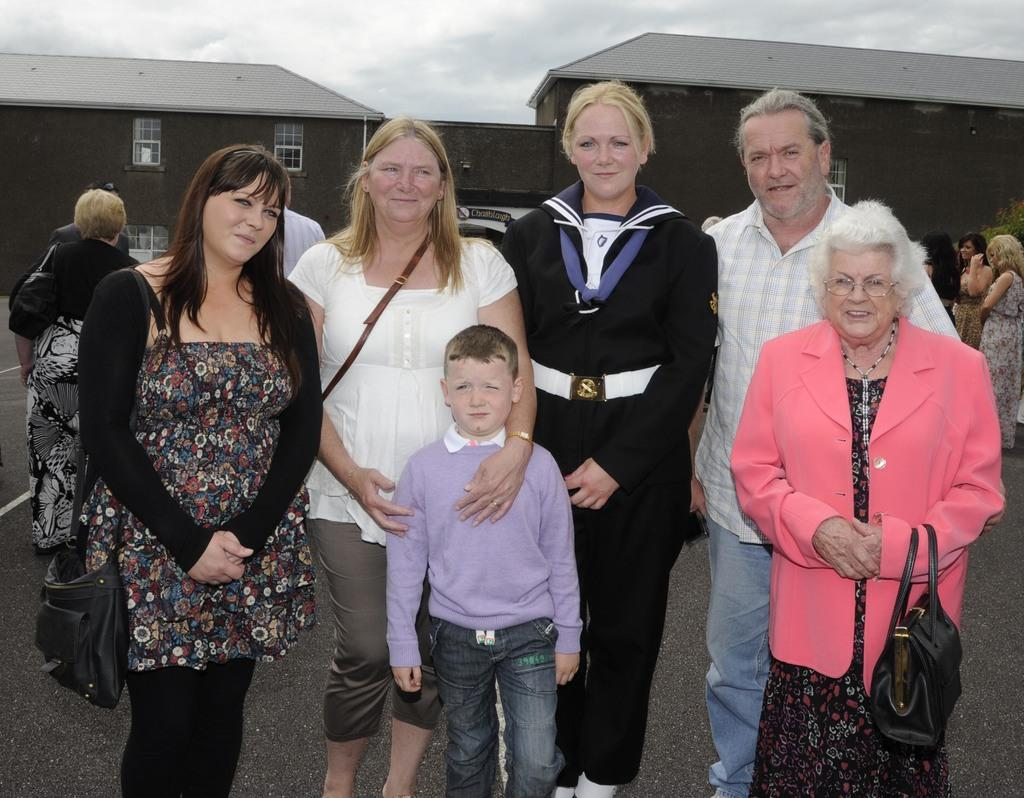How many people are standing and smiling in the image? There are six persons standing and smiling in the image. What can be seen in the background of the image? There is a group of people standing in the background of the image, as well as buildings and the sky. What type of shirt is the slave wearing in the image? There is no slave or shirt present in the image. 